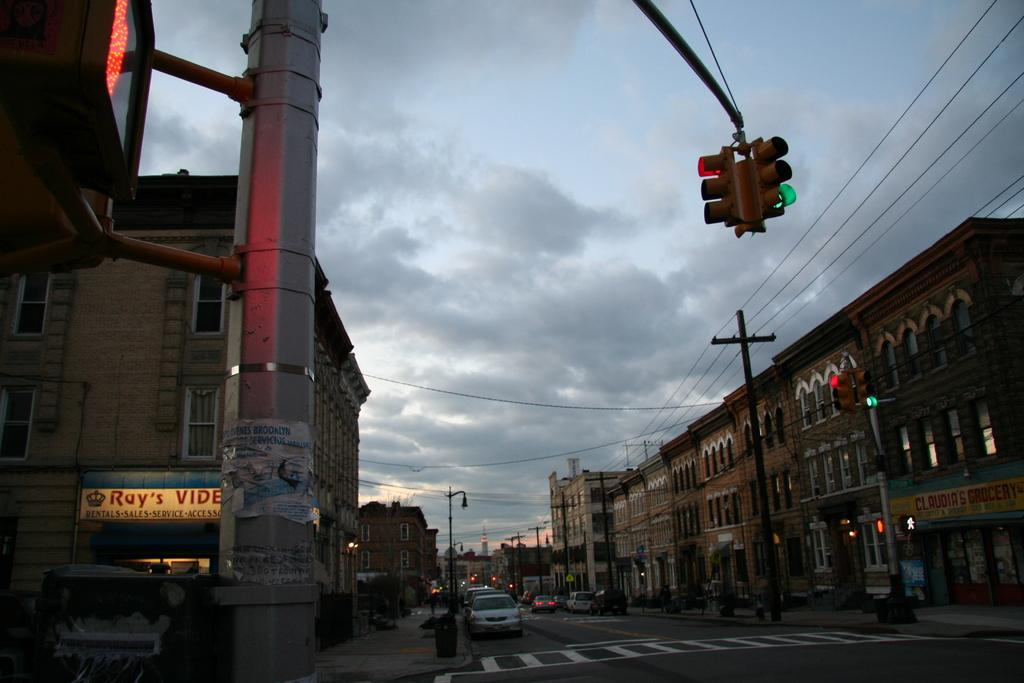<image>
Give a short and clear explanation of the subsequent image. Ray's video store is across the street from Claudia's grocery. 